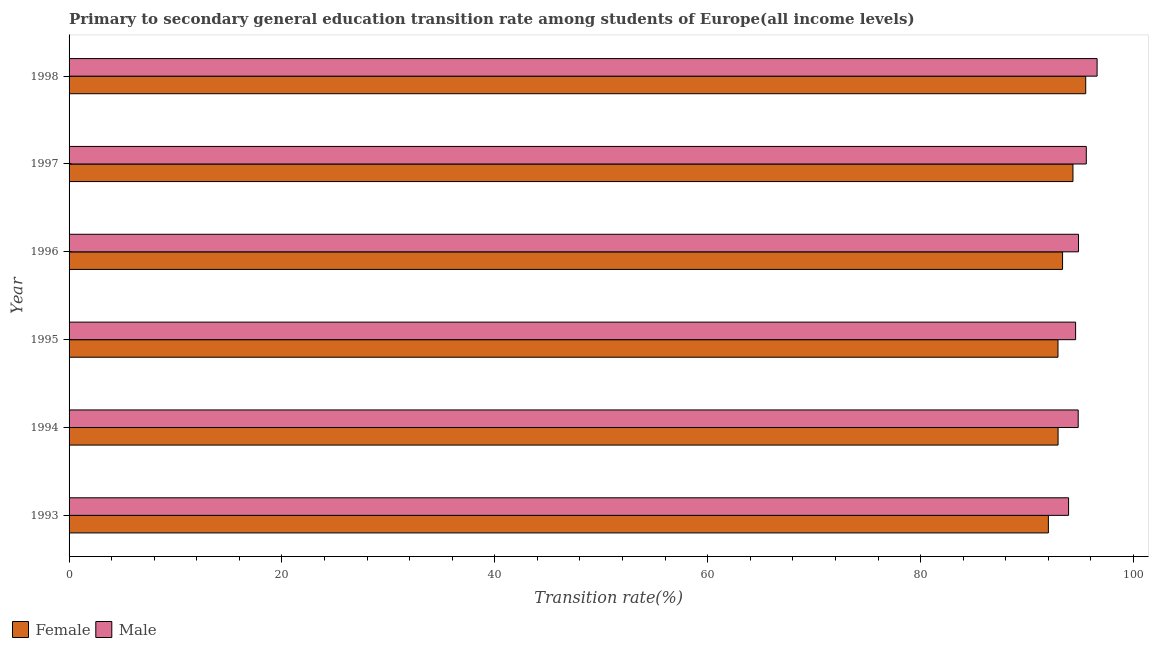How many groups of bars are there?
Your response must be concise. 6. How many bars are there on the 5th tick from the bottom?
Provide a short and direct response. 2. What is the transition rate among male students in 1997?
Keep it short and to the point. 95.57. Across all years, what is the maximum transition rate among male students?
Provide a short and direct response. 96.58. Across all years, what is the minimum transition rate among female students?
Give a very brief answer. 92.01. What is the total transition rate among male students in the graph?
Offer a very short reply. 570.27. What is the difference between the transition rate among male students in 1993 and that in 1998?
Give a very brief answer. -2.68. What is the difference between the transition rate among male students in 1994 and the transition rate among female students in 1993?
Keep it short and to the point. 2.8. What is the average transition rate among female students per year?
Give a very brief answer. 93.5. In the year 1995, what is the difference between the transition rate among female students and transition rate among male students?
Provide a succinct answer. -1.66. What is the ratio of the transition rate among male students in 1997 to that in 1998?
Make the answer very short. 0.99. Is the transition rate among female students in 1995 less than that in 1997?
Make the answer very short. Yes. Is the difference between the transition rate among female students in 1993 and 1995 greater than the difference between the transition rate among male students in 1993 and 1995?
Provide a succinct answer. No. What is the difference between the highest and the second highest transition rate among female students?
Provide a succinct answer. 1.2. What is the difference between the highest and the lowest transition rate among female students?
Keep it short and to the point. 3.51. What does the 2nd bar from the bottom in 1994 represents?
Your answer should be very brief. Male. How many bars are there?
Your answer should be compact. 12. Are all the bars in the graph horizontal?
Offer a terse response. Yes. How many years are there in the graph?
Give a very brief answer. 6. Are the values on the major ticks of X-axis written in scientific E-notation?
Ensure brevity in your answer.  No. Does the graph contain any zero values?
Keep it short and to the point. No. Does the graph contain grids?
Offer a very short reply. No. Where does the legend appear in the graph?
Keep it short and to the point. Bottom left. What is the title of the graph?
Keep it short and to the point. Primary to secondary general education transition rate among students of Europe(all income levels). Does "Constant 2005 US$" appear as one of the legend labels in the graph?
Your answer should be compact. No. What is the label or title of the X-axis?
Your response must be concise. Transition rate(%). What is the Transition rate(%) in Female in 1993?
Keep it short and to the point. 92.01. What is the Transition rate(%) of Male in 1993?
Make the answer very short. 93.9. What is the Transition rate(%) in Female in 1994?
Your response must be concise. 92.92. What is the Transition rate(%) of Male in 1994?
Provide a succinct answer. 94.81. What is the Transition rate(%) in Female in 1995?
Provide a short and direct response. 92.91. What is the Transition rate(%) of Male in 1995?
Offer a terse response. 94.56. What is the Transition rate(%) of Female in 1996?
Your answer should be compact. 93.34. What is the Transition rate(%) of Male in 1996?
Provide a short and direct response. 94.84. What is the Transition rate(%) in Female in 1997?
Your response must be concise. 94.32. What is the Transition rate(%) of Male in 1997?
Give a very brief answer. 95.57. What is the Transition rate(%) of Female in 1998?
Give a very brief answer. 95.51. What is the Transition rate(%) of Male in 1998?
Make the answer very short. 96.58. Across all years, what is the maximum Transition rate(%) of Female?
Offer a terse response. 95.51. Across all years, what is the maximum Transition rate(%) in Male?
Your answer should be compact. 96.58. Across all years, what is the minimum Transition rate(%) of Female?
Offer a very short reply. 92.01. Across all years, what is the minimum Transition rate(%) of Male?
Provide a short and direct response. 93.9. What is the total Transition rate(%) of Female in the graph?
Your answer should be compact. 561.01. What is the total Transition rate(%) of Male in the graph?
Provide a short and direct response. 570.27. What is the difference between the Transition rate(%) of Female in 1993 and that in 1994?
Your response must be concise. -0.91. What is the difference between the Transition rate(%) in Male in 1993 and that in 1994?
Your answer should be very brief. -0.9. What is the difference between the Transition rate(%) in Female in 1993 and that in 1995?
Offer a very short reply. -0.9. What is the difference between the Transition rate(%) of Male in 1993 and that in 1995?
Offer a terse response. -0.66. What is the difference between the Transition rate(%) in Female in 1993 and that in 1996?
Provide a short and direct response. -1.33. What is the difference between the Transition rate(%) in Male in 1993 and that in 1996?
Make the answer very short. -0.93. What is the difference between the Transition rate(%) in Female in 1993 and that in 1997?
Your answer should be very brief. -2.31. What is the difference between the Transition rate(%) of Male in 1993 and that in 1997?
Ensure brevity in your answer.  -1.67. What is the difference between the Transition rate(%) in Female in 1993 and that in 1998?
Give a very brief answer. -3.51. What is the difference between the Transition rate(%) in Male in 1993 and that in 1998?
Offer a terse response. -2.68. What is the difference between the Transition rate(%) of Female in 1994 and that in 1995?
Provide a succinct answer. 0.01. What is the difference between the Transition rate(%) in Male in 1994 and that in 1995?
Your answer should be compact. 0.24. What is the difference between the Transition rate(%) of Female in 1994 and that in 1996?
Provide a succinct answer. -0.42. What is the difference between the Transition rate(%) of Male in 1994 and that in 1996?
Make the answer very short. -0.03. What is the difference between the Transition rate(%) of Female in 1994 and that in 1997?
Offer a terse response. -1.4. What is the difference between the Transition rate(%) of Male in 1994 and that in 1997?
Your answer should be compact. -0.76. What is the difference between the Transition rate(%) in Female in 1994 and that in 1998?
Provide a succinct answer. -2.6. What is the difference between the Transition rate(%) in Male in 1994 and that in 1998?
Make the answer very short. -1.77. What is the difference between the Transition rate(%) of Female in 1995 and that in 1996?
Your answer should be compact. -0.43. What is the difference between the Transition rate(%) in Male in 1995 and that in 1996?
Provide a succinct answer. -0.27. What is the difference between the Transition rate(%) of Female in 1995 and that in 1997?
Offer a very short reply. -1.41. What is the difference between the Transition rate(%) in Male in 1995 and that in 1997?
Offer a terse response. -1.01. What is the difference between the Transition rate(%) of Female in 1995 and that in 1998?
Your answer should be very brief. -2.61. What is the difference between the Transition rate(%) of Male in 1995 and that in 1998?
Your answer should be very brief. -2.02. What is the difference between the Transition rate(%) in Female in 1996 and that in 1997?
Your response must be concise. -0.98. What is the difference between the Transition rate(%) in Male in 1996 and that in 1997?
Your answer should be very brief. -0.73. What is the difference between the Transition rate(%) in Female in 1996 and that in 1998?
Your answer should be compact. -2.17. What is the difference between the Transition rate(%) in Male in 1996 and that in 1998?
Your response must be concise. -1.75. What is the difference between the Transition rate(%) of Female in 1997 and that in 1998?
Keep it short and to the point. -1.2. What is the difference between the Transition rate(%) of Male in 1997 and that in 1998?
Your response must be concise. -1.01. What is the difference between the Transition rate(%) of Female in 1993 and the Transition rate(%) of Male in 1994?
Make the answer very short. -2.8. What is the difference between the Transition rate(%) of Female in 1993 and the Transition rate(%) of Male in 1995?
Offer a terse response. -2.56. What is the difference between the Transition rate(%) of Female in 1993 and the Transition rate(%) of Male in 1996?
Give a very brief answer. -2.83. What is the difference between the Transition rate(%) in Female in 1993 and the Transition rate(%) in Male in 1997?
Give a very brief answer. -3.56. What is the difference between the Transition rate(%) in Female in 1993 and the Transition rate(%) in Male in 1998?
Your response must be concise. -4.58. What is the difference between the Transition rate(%) of Female in 1994 and the Transition rate(%) of Male in 1995?
Your response must be concise. -1.65. What is the difference between the Transition rate(%) in Female in 1994 and the Transition rate(%) in Male in 1996?
Make the answer very short. -1.92. What is the difference between the Transition rate(%) of Female in 1994 and the Transition rate(%) of Male in 1997?
Provide a succinct answer. -2.65. What is the difference between the Transition rate(%) in Female in 1994 and the Transition rate(%) in Male in 1998?
Your response must be concise. -3.67. What is the difference between the Transition rate(%) in Female in 1995 and the Transition rate(%) in Male in 1996?
Provide a short and direct response. -1.93. What is the difference between the Transition rate(%) in Female in 1995 and the Transition rate(%) in Male in 1997?
Your response must be concise. -2.66. What is the difference between the Transition rate(%) in Female in 1995 and the Transition rate(%) in Male in 1998?
Offer a very short reply. -3.67. What is the difference between the Transition rate(%) in Female in 1996 and the Transition rate(%) in Male in 1997?
Your answer should be compact. -2.23. What is the difference between the Transition rate(%) in Female in 1996 and the Transition rate(%) in Male in 1998?
Give a very brief answer. -3.24. What is the difference between the Transition rate(%) in Female in 1997 and the Transition rate(%) in Male in 1998?
Keep it short and to the point. -2.27. What is the average Transition rate(%) of Female per year?
Give a very brief answer. 93.5. What is the average Transition rate(%) in Male per year?
Your response must be concise. 95.05. In the year 1993, what is the difference between the Transition rate(%) in Female and Transition rate(%) in Male?
Give a very brief answer. -1.9. In the year 1994, what is the difference between the Transition rate(%) of Female and Transition rate(%) of Male?
Ensure brevity in your answer.  -1.89. In the year 1995, what is the difference between the Transition rate(%) in Female and Transition rate(%) in Male?
Offer a terse response. -1.66. In the year 1996, what is the difference between the Transition rate(%) in Female and Transition rate(%) in Male?
Offer a terse response. -1.5. In the year 1997, what is the difference between the Transition rate(%) in Female and Transition rate(%) in Male?
Offer a terse response. -1.25. In the year 1998, what is the difference between the Transition rate(%) of Female and Transition rate(%) of Male?
Keep it short and to the point. -1.07. What is the ratio of the Transition rate(%) in Female in 1993 to that in 1994?
Provide a short and direct response. 0.99. What is the ratio of the Transition rate(%) in Female in 1993 to that in 1995?
Keep it short and to the point. 0.99. What is the ratio of the Transition rate(%) in Male in 1993 to that in 1995?
Offer a terse response. 0.99. What is the ratio of the Transition rate(%) of Female in 1993 to that in 1996?
Ensure brevity in your answer.  0.99. What is the ratio of the Transition rate(%) of Male in 1993 to that in 1996?
Make the answer very short. 0.99. What is the ratio of the Transition rate(%) of Female in 1993 to that in 1997?
Your answer should be very brief. 0.98. What is the ratio of the Transition rate(%) of Male in 1993 to that in 1997?
Offer a terse response. 0.98. What is the ratio of the Transition rate(%) in Female in 1993 to that in 1998?
Offer a very short reply. 0.96. What is the ratio of the Transition rate(%) of Male in 1993 to that in 1998?
Your response must be concise. 0.97. What is the ratio of the Transition rate(%) of Female in 1994 to that in 1995?
Give a very brief answer. 1. What is the ratio of the Transition rate(%) in Female in 1994 to that in 1997?
Your response must be concise. 0.99. What is the ratio of the Transition rate(%) in Male in 1994 to that in 1997?
Your answer should be compact. 0.99. What is the ratio of the Transition rate(%) of Female in 1994 to that in 1998?
Provide a short and direct response. 0.97. What is the ratio of the Transition rate(%) of Male in 1994 to that in 1998?
Give a very brief answer. 0.98. What is the ratio of the Transition rate(%) of Female in 1995 to that in 1996?
Offer a terse response. 1. What is the ratio of the Transition rate(%) of Male in 1995 to that in 1996?
Keep it short and to the point. 1. What is the ratio of the Transition rate(%) in Female in 1995 to that in 1997?
Keep it short and to the point. 0.99. What is the ratio of the Transition rate(%) of Female in 1995 to that in 1998?
Your answer should be very brief. 0.97. What is the ratio of the Transition rate(%) of Male in 1995 to that in 1998?
Offer a terse response. 0.98. What is the ratio of the Transition rate(%) in Female in 1996 to that in 1997?
Your response must be concise. 0.99. What is the ratio of the Transition rate(%) in Female in 1996 to that in 1998?
Give a very brief answer. 0.98. What is the ratio of the Transition rate(%) in Male in 1996 to that in 1998?
Provide a succinct answer. 0.98. What is the ratio of the Transition rate(%) in Female in 1997 to that in 1998?
Ensure brevity in your answer.  0.99. What is the difference between the highest and the second highest Transition rate(%) in Female?
Your answer should be very brief. 1.2. What is the difference between the highest and the second highest Transition rate(%) of Male?
Your answer should be compact. 1.01. What is the difference between the highest and the lowest Transition rate(%) in Female?
Provide a short and direct response. 3.51. What is the difference between the highest and the lowest Transition rate(%) in Male?
Give a very brief answer. 2.68. 